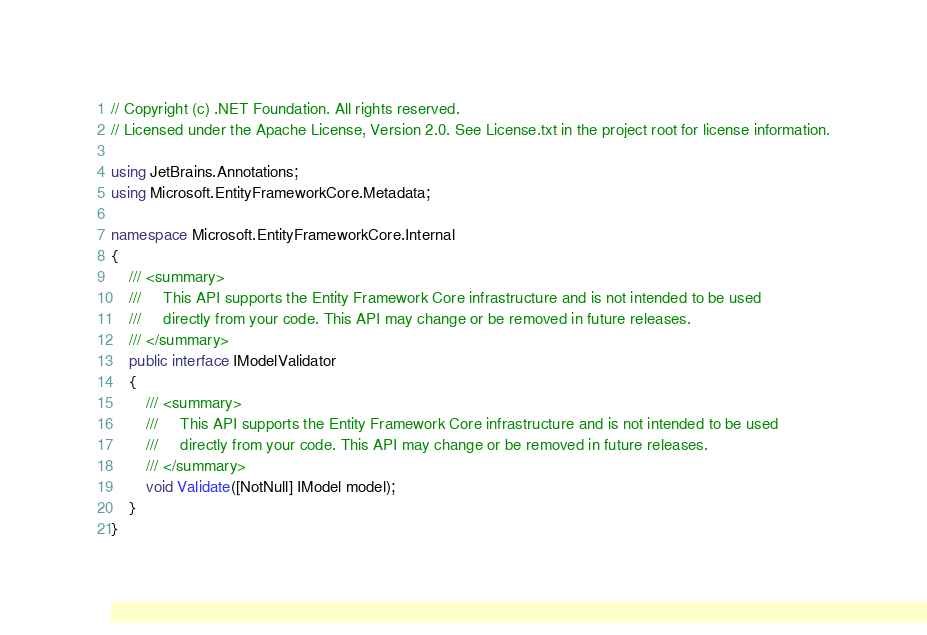<code> <loc_0><loc_0><loc_500><loc_500><_C#_>// Copyright (c) .NET Foundation. All rights reserved.
// Licensed under the Apache License, Version 2.0. See License.txt in the project root for license information.

using JetBrains.Annotations;
using Microsoft.EntityFrameworkCore.Metadata;

namespace Microsoft.EntityFrameworkCore.Internal
{
    /// <summary>
    ///     This API supports the Entity Framework Core infrastructure and is not intended to be used
    ///     directly from your code. This API may change or be removed in future releases.
    /// </summary>
    public interface IModelValidator
    {
        /// <summary>
        ///     This API supports the Entity Framework Core infrastructure and is not intended to be used
        ///     directly from your code. This API may change or be removed in future releases.
        /// </summary>
        void Validate([NotNull] IModel model);
    }
}
</code> 